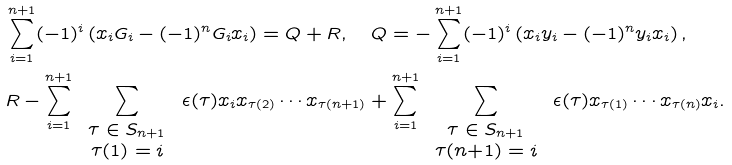<formula> <loc_0><loc_0><loc_500><loc_500>& \sum _ { i = 1 } ^ { n + 1 } ( - 1 ) ^ { i } \left ( x _ { i } G _ { i } - ( - 1 ) ^ { n } G _ { i } x _ { i } \right ) = Q + R , \quad Q = - \sum _ { i = 1 } ^ { n + 1 } ( - 1 ) ^ { i } \left ( x _ { i } y _ { i } - ( - 1 ) ^ { n } y _ { i } x _ { i } \right ) , \\ & R - \sum _ { i = 1 } ^ { n + 1 } \, \sum _ { \begin{array} { c } \tau \in S _ { n + 1 } \\ \tau ( 1 ) = i \end{array} } \, \epsilon ( \tau ) x _ { i } x _ { \tau ( 2 ) } \cdots x _ { \tau ( n + 1 ) } + \sum _ { i = 1 } ^ { n + 1 } \, \sum _ { \begin{array} { c } \tau \in S _ { n + 1 } \\ \tau ( n { + } 1 ) = i \end{array} } \, \epsilon ( \tau ) x _ { \tau ( 1 ) } \cdots x _ { \tau ( n ) } x _ { i } .</formula> 